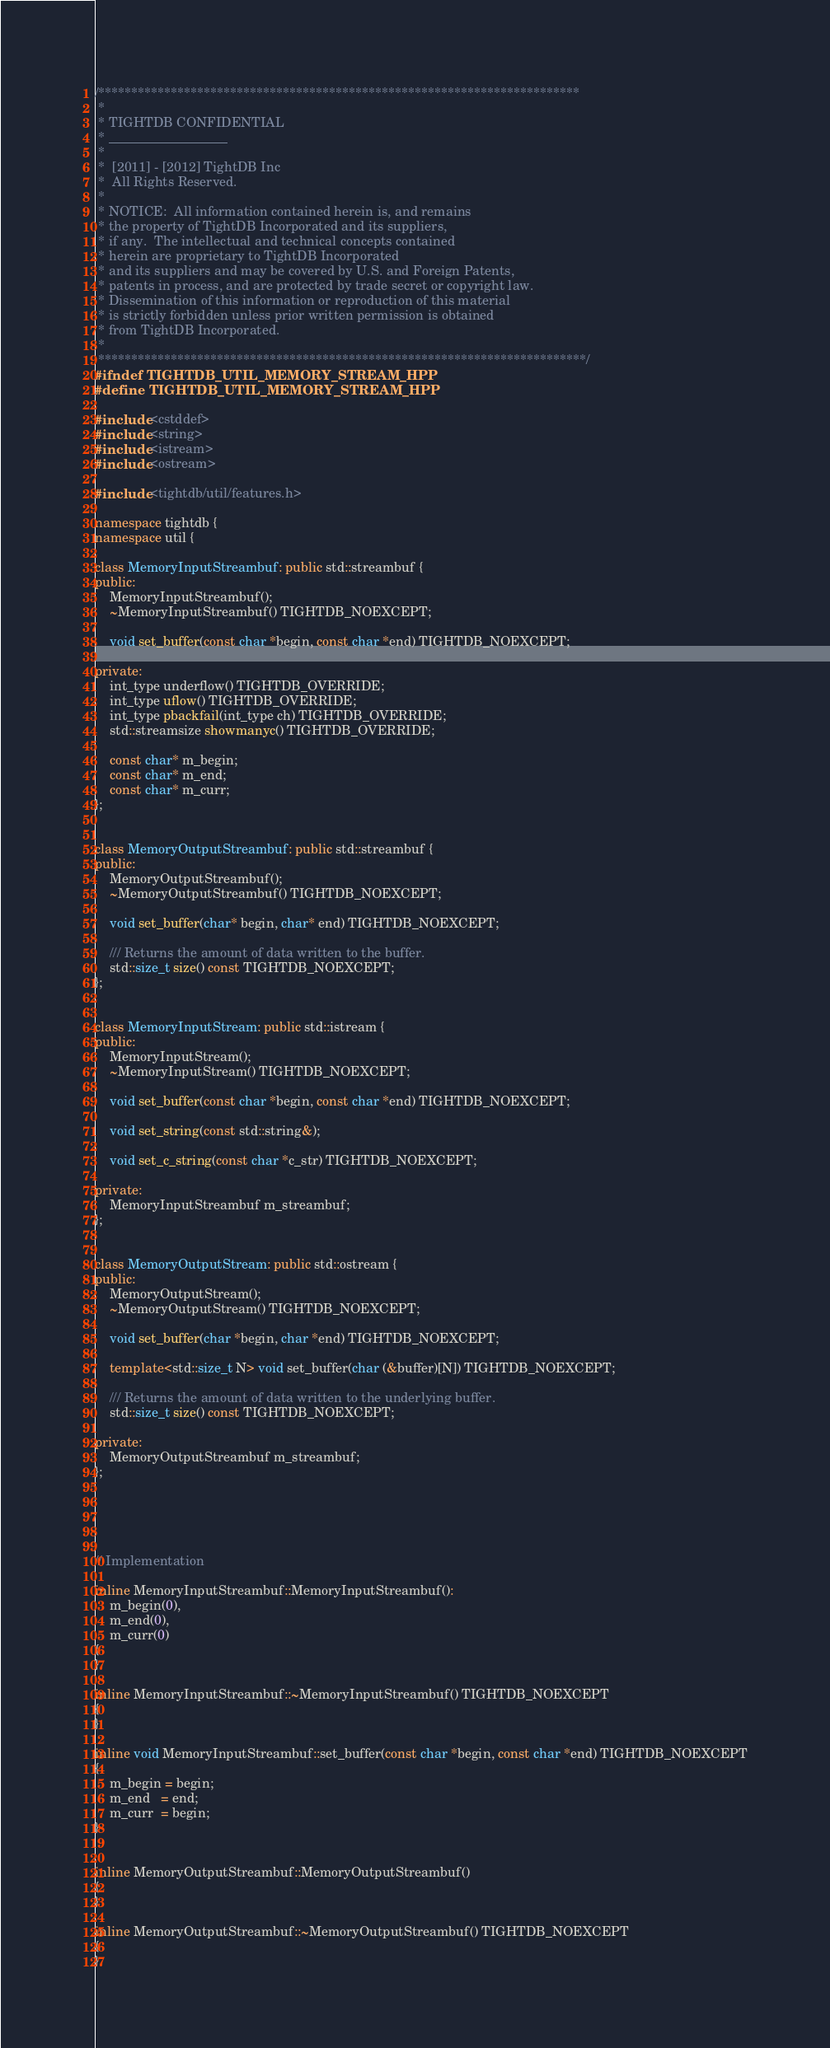<code> <loc_0><loc_0><loc_500><loc_500><_C++_>/*************************************************************************
 *
 * TIGHTDB CONFIDENTIAL
 * __________________
 *
 *  [2011] - [2012] TightDB Inc
 *  All Rights Reserved.
 *
 * NOTICE:  All information contained herein is, and remains
 * the property of TightDB Incorporated and its suppliers,
 * if any.  The intellectual and technical concepts contained
 * herein are proprietary to TightDB Incorporated
 * and its suppliers and may be covered by U.S. and Foreign Patents,
 * patents in process, and are protected by trade secret or copyright law.
 * Dissemination of this information or reproduction of this material
 * is strictly forbidden unless prior written permission is obtained
 * from TightDB Incorporated.
 *
 **************************************************************************/
#ifndef TIGHTDB_UTIL_MEMORY_STREAM_HPP
#define TIGHTDB_UTIL_MEMORY_STREAM_HPP

#include <cstddef>
#include <string>
#include <istream>
#include <ostream>

#include <tightdb/util/features.h>

namespace tightdb {
namespace util {

class MemoryInputStreambuf: public std::streambuf {
public:
    MemoryInputStreambuf();
    ~MemoryInputStreambuf() TIGHTDB_NOEXCEPT;

    void set_buffer(const char *begin, const char *end) TIGHTDB_NOEXCEPT;

private:
    int_type underflow() TIGHTDB_OVERRIDE;
    int_type uflow() TIGHTDB_OVERRIDE;
    int_type pbackfail(int_type ch) TIGHTDB_OVERRIDE;
    std::streamsize showmanyc() TIGHTDB_OVERRIDE;

    const char* m_begin;
    const char* m_end;
    const char* m_curr;
};


class MemoryOutputStreambuf: public std::streambuf {
public:
    MemoryOutputStreambuf();
    ~MemoryOutputStreambuf() TIGHTDB_NOEXCEPT;

    void set_buffer(char* begin, char* end) TIGHTDB_NOEXCEPT;

    /// Returns the amount of data written to the buffer.
    std::size_t size() const TIGHTDB_NOEXCEPT;
};


class MemoryInputStream: public std::istream {
public:
    MemoryInputStream();
    ~MemoryInputStream() TIGHTDB_NOEXCEPT;

    void set_buffer(const char *begin, const char *end) TIGHTDB_NOEXCEPT;

    void set_string(const std::string&);

    void set_c_string(const char *c_str) TIGHTDB_NOEXCEPT;

private:
    MemoryInputStreambuf m_streambuf;
};


class MemoryOutputStream: public std::ostream {
public:
    MemoryOutputStream();
    ~MemoryOutputStream() TIGHTDB_NOEXCEPT;

    void set_buffer(char *begin, char *end) TIGHTDB_NOEXCEPT;

    template<std::size_t N> void set_buffer(char (&buffer)[N]) TIGHTDB_NOEXCEPT;

    /// Returns the amount of data written to the underlying buffer.
    std::size_t size() const TIGHTDB_NOEXCEPT;

private:
    MemoryOutputStreambuf m_streambuf;
};





// Implementation

inline MemoryInputStreambuf::MemoryInputStreambuf():
    m_begin(0),
    m_end(0),
    m_curr(0)
{
}

inline MemoryInputStreambuf::~MemoryInputStreambuf() TIGHTDB_NOEXCEPT
{
}

inline void MemoryInputStreambuf::set_buffer(const char *begin, const char *end) TIGHTDB_NOEXCEPT
{
    m_begin = begin;
    m_end   = end;
    m_curr  = begin;
}


inline MemoryOutputStreambuf::MemoryOutputStreambuf()
{
}

inline MemoryOutputStreambuf::~MemoryOutputStreambuf() TIGHTDB_NOEXCEPT
{
}
</code> 